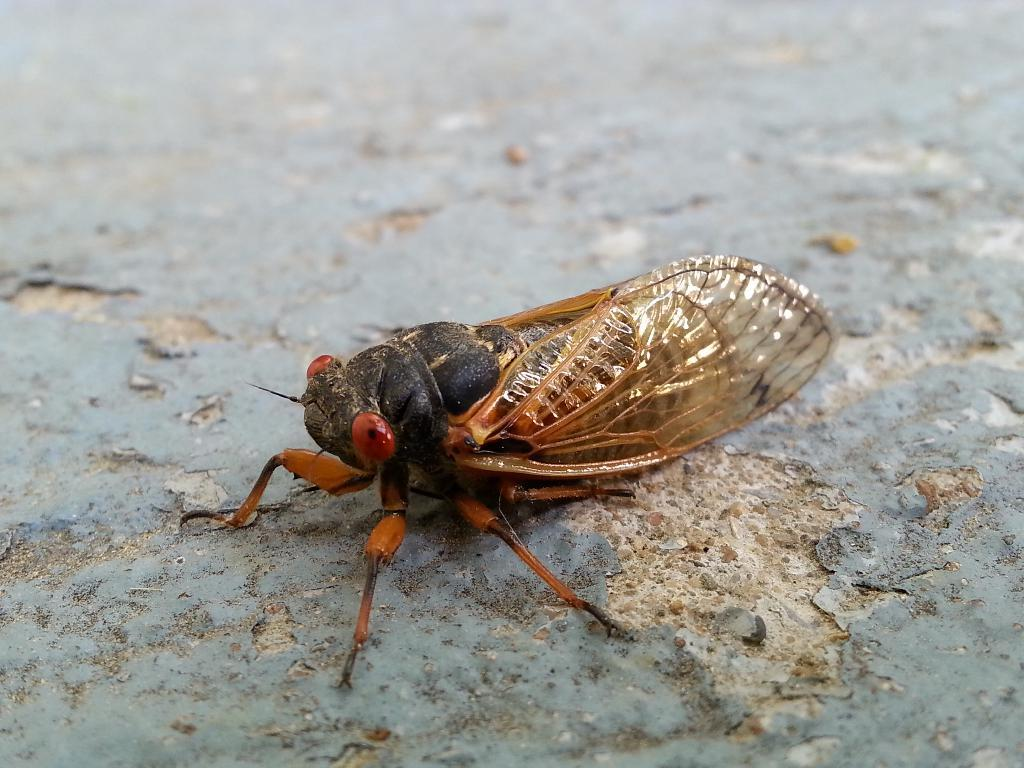What type of creature can be seen in the image? There is an insect in the image. What is visible behind the insect? There is a floor visible in the background of the image. What book is the insect reading in the image? There is no book present in the image; it only features an insect and a floor. 